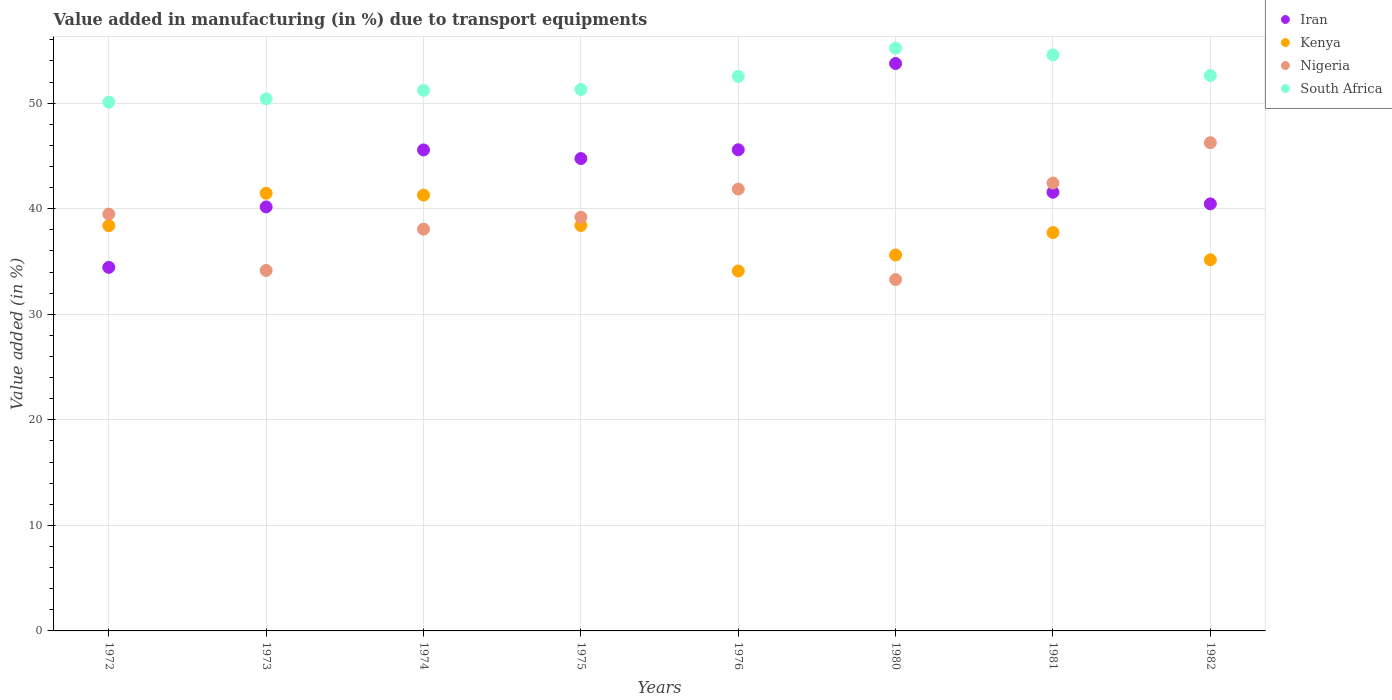How many different coloured dotlines are there?
Give a very brief answer. 4. Is the number of dotlines equal to the number of legend labels?
Your answer should be compact. Yes. What is the percentage of value added in manufacturing due to transport equipments in Nigeria in 1980?
Give a very brief answer. 33.29. Across all years, what is the maximum percentage of value added in manufacturing due to transport equipments in Kenya?
Your answer should be very brief. 41.46. Across all years, what is the minimum percentage of value added in manufacturing due to transport equipments in South Africa?
Make the answer very short. 50.09. In which year was the percentage of value added in manufacturing due to transport equipments in Iran minimum?
Make the answer very short. 1972. What is the total percentage of value added in manufacturing due to transport equipments in Nigeria in the graph?
Keep it short and to the point. 314.71. What is the difference between the percentage of value added in manufacturing due to transport equipments in Kenya in 1973 and that in 1974?
Offer a terse response. 0.17. What is the difference between the percentage of value added in manufacturing due to transport equipments in Kenya in 1973 and the percentage of value added in manufacturing due to transport equipments in South Africa in 1980?
Ensure brevity in your answer.  -13.75. What is the average percentage of value added in manufacturing due to transport equipments in Iran per year?
Keep it short and to the point. 43.28. In the year 1976, what is the difference between the percentage of value added in manufacturing due to transport equipments in Kenya and percentage of value added in manufacturing due to transport equipments in South Africa?
Make the answer very short. -18.43. What is the ratio of the percentage of value added in manufacturing due to transport equipments in Nigeria in 1980 to that in 1981?
Make the answer very short. 0.78. Is the percentage of value added in manufacturing due to transport equipments in Nigeria in 1974 less than that in 1982?
Your response must be concise. Yes. Is the difference between the percentage of value added in manufacturing due to transport equipments in Kenya in 1975 and 1980 greater than the difference between the percentage of value added in manufacturing due to transport equipments in South Africa in 1975 and 1980?
Ensure brevity in your answer.  Yes. What is the difference between the highest and the second highest percentage of value added in manufacturing due to transport equipments in Nigeria?
Offer a very short reply. 3.82. What is the difference between the highest and the lowest percentage of value added in manufacturing due to transport equipments in Nigeria?
Offer a terse response. 12.96. Is the sum of the percentage of value added in manufacturing due to transport equipments in Iran in 1972 and 1981 greater than the maximum percentage of value added in manufacturing due to transport equipments in South Africa across all years?
Ensure brevity in your answer.  Yes. Is it the case that in every year, the sum of the percentage of value added in manufacturing due to transport equipments in Iran and percentage of value added in manufacturing due to transport equipments in South Africa  is greater than the percentage of value added in manufacturing due to transport equipments in Kenya?
Give a very brief answer. Yes. Does the percentage of value added in manufacturing due to transport equipments in Kenya monotonically increase over the years?
Offer a very short reply. No. Is the percentage of value added in manufacturing due to transport equipments in Nigeria strictly less than the percentage of value added in manufacturing due to transport equipments in Kenya over the years?
Keep it short and to the point. No. How many dotlines are there?
Offer a very short reply. 4. How many years are there in the graph?
Your response must be concise. 8. What is the difference between two consecutive major ticks on the Y-axis?
Keep it short and to the point. 10. Are the values on the major ticks of Y-axis written in scientific E-notation?
Your answer should be very brief. No. Does the graph contain any zero values?
Ensure brevity in your answer.  No. How many legend labels are there?
Your answer should be compact. 4. What is the title of the graph?
Keep it short and to the point. Value added in manufacturing (in %) due to transport equipments. Does "Curacao" appear as one of the legend labels in the graph?
Provide a short and direct response. No. What is the label or title of the Y-axis?
Keep it short and to the point. Value added (in %). What is the Value added (in %) of Iran in 1972?
Provide a succinct answer. 34.44. What is the Value added (in %) in Kenya in 1972?
Ensure brevity in your answer.  38.39. What is the Value added (in %) of Nigeria in 1972?
Your response must be concise. 39.49. What is the Value added (in %) in South Africa in 1972?
Give a very brief answer. 50.09. What is the Value added (in %) of Iran in 1973?
Offer a terse response. 40.17. What is the Value added (in %) in Kenya in 1973?
Your response must be concise. 41.46. What is the Value added (in %) in Nigeria in 1973?
Your answer should be compact. 34.15. What is the Value added (in %) of South Africa in 1973?
Your answer should be compact. 50.41. What is the Value added (in %) in Iran in 1974?
Keep it short and to the point. 45.57. What is the Value added (in %) of Kenya in 1974?
Make the answer very short. 41.29. What is the Value added (in %) of Nigeria in 1974?
Keep it short and to the point. 38.06. What is the Value added (in %) of South Africa in 1974?
Give a very brief answer. 51.21. What is the Value added (in %) in Iran in 1975?
Keep it short and to the point. 44.75. What is the Value added (in %) in Kenya in 1975?
Ensure brevity in your answer.  38.41. What is the Value added (in %) in Nigeria in 1975?
Give a very brief answer. 39.19. What is the Value added (in %) in South Africa in 1975?
Ensure brevity in your answer.  51.29. What is the Value added (in %) of Iran in 1976?
Make the answer very short. 45.58. What is the Value added (in %) of Kenya in 1976?
Your answer should be compact. 34.1. What is the Value added (in %) of Nigeria in 1976?
Offer a very short reply. 41.86. What is the Value added (in %) of South Africa in 1976?
Make the answer very short. 52.53. What is the Value added (in %) of Iran in 1980?
Provide a succinct answer. 53.75. What is the Value added (in %) of Kenya in 1980?
Your response must be concise. 35.61. What is the Value added (in %) in Nigeria in 1980?
Provide a short and direct response. 33.29. What is the Value added (in %) in South Africa in 1980?
Your response must be concise. 55.21. What is the Value added (in %) of Iran in 1981?
Keep it short and to the point. 41.56. What is the Value added (in %) in Kenya in 1981?
Offer a terse response. 37.74. What is the Value added (in %) in Nigeria in 1981?
Ensure brevity in your answer.  42.43. What is the Value added (in %) in South Africa in 1981?
Give a very brief answer. 54.56. What is the Value added (in %) in Iran in 1982?
Your answer should be compact. 40.46. What is the Value added (in %) in Kenya in 1982?
Your answer should be compact. 35.16. What is the Value added (in %) of Nigeria in 1982?
Your answer should be compact. 46.25. What is the Value added (in %) in South Africa in 1982?
Provide a short and direct response. 52.62. Across all years, what is the maximum Value added (in %) of Iran?
Ensure brevity in your answer.  53.75. Across all years, what is the maximum Value added (in %) in Kenya?
Your answer should be very brief. 41.46. Across all years, what is the maximum Value added (in %) in Nigeria?
Offer a terse response. 46.25. Across all years, what is the maximum Value added (in %) in South Africa?
Provide a short and direct response. 55.21. Across all years, what is the minimum Value added (in %) in Iran?
Keep it short and to the point. 34.44. Across all years, what is the minimum Value added (in %) in Kenya?
Your answer should be compact. 34.1. Across all years, what is the minimum Value added (in %) in Nigeria?
Offer a very short reply. 33.29. Across all years, what is the minimum Value added (in %) of South Africa?
Make the answer very short. 50.09. What is the total Value added (in %) of Iran in the graph?
Offer a terse response. 346.27. What is the total Value added (in %) of Kenya in the graph?
Ensure brevity in your answer.  302.16. What is the total Value added (in %) of Nigeria in the graph?
Your response must be concise. 314.71. What is the total Value added (in %) in South Africa in the graph?
Ensure brevity in your answer.  417.92. What is the difference between the Value added (in %) of Iran in 1972 and that in 1973?
Your answer should be compact. -5.73. What is the difference between the Value added (in %) in Kenya in 1972 and that in 1973?
Offer a terse response. -3.07. What is the difference between the Value added (in %) in Nigeria in 1972 and that in 1973?
Your answer should be very brief. 5.34. What is the difference between the Value added (in %) in South Africa in 1972 and that in 1973?
Ensure brevity in your answer.  -0.31. What is the difference between the Value added (in %) of Iran in 1972 and that in 1974?
Offer a terse response. -11.13. What is the difference between the Value added (in %) in Kenya in 1972 and that in 1974?
Offer a very short reply. -2.89. What is the difference between the Value added (in %) in Nigeria in 1972 and that in 1974?
Your response must be concise. 1.43. What is the difference between the Value added (in %) of South Africa in 1972 and that in 1974?
Give a very brief answer. -1.11. What is the difference between the Value added (in %) in Iran in 1972 and that in 1975?
Your answer should be very brief. -10.31. What is the difference between the Value added (in %) in Kenya in 1972 and that in 1975?
Keep it short and to the point. -0.02. What is the difference between the Value added (in %) of Nigeria in 1972 and that in 1975?
Offer a very short reply. 0.3. What is the difference between the Value added (in %) of South Africa in 1972 and that in 1975?
Keep it short and to the point. -1.2. What is the difference between the Value added (in %) in Iran in 1972 and that in 1976?
Your answer should be very brief. -11.14. What is the difference between the Value added (in %) in Kenya in 1972 and that in 1976?
Your answer should be compact. 4.29. What is the difference between the Value added (in %) in Nigeria in 1972 and that in 1976?
Provide a succinct answer. -2.37. What is the difference between the Value added (in %) in South Africa in 1972 and that in 1976?
Your answer should be compact. -2.44. What is the difference between the Value added (in %) in Iran in 1972 and that in 1980?
Provide a short and direct response. -19.31. What is the difference between the Value added (in %) of Kenya in 1972 and that in 1980?
Your response must be concise. 2.78. What is the difference between the Value added (in %) of Nigeria in 1972 and that in 1980?
Make the answer very short. 6.2. What is the difference between the Value added (in %) in South Africa in 1972 and that in 1980?
Provide a succinct answer. -5.12. What is the difference between the Value added (in %) of Iran in 1972 and that in 1981?
Offer a very short reply. -7.12. What is the difference between the Value added (in %) in Kenya in 1972 and that in 1981?
Your answer should be compact. 0.65. What is the difference between the Value added (in %) of Nigeria in 1972 and that in 1981?
Your answer should be compact. -2.94. What is the difference between the Value added (in %) in South Africa in 1972 and that in 1981?
Your response must be concise. -4.47. What is the difference between the Value added (in %) of Iran in 1972 and that in 1982?
Keep it short and to the point. -6.02. What is the difference between the Value added (in %) in Kenya in 1972 and that in 1982?
Give a very brief answer. 3.23. What is the difference between the Value added (in %) of Nigeria in 1972 and that in 1982?
Keep it short and to the point. -6.76. What is the difference between the Value added (in %) of South Africa in 1972 and that in 1982?
Your response must be concise. -2.53. What is the difference between the Value added (in %) in Iran in 1973 and that in 1974?
Offer a very short reply. -5.4. What is the difference between the Value added (in %) of Kenya in 1973 and that in 1974?
Offer a very short reply. 0.17. What is the difference between the Value added (in %) in Nigeria in 1973 and that in 1974?
Ensure brevity in your answer.  -3.91. What is the difference between the Value added (in %) of South Africa in 1973 and that in 1974?
Make the answer very short. -0.8. What is the difference between the Value added (in %) of Iran in 1973 and that in 1975?
Provide a short and direct response. -4.58. What is the difference between the Value added (in %) of Kenya in 1973 and that in 1975?
Your answer should be compact. 3.05. What is the difference between the Value added (in %) in Nigeria in 1973 and that in 1975?
Offer a terse response. -5.04. What is the difference between the Value added (in %) in South Africa in 1973 and that in 1975?
Make the answer very short. -0.88. What is the difference between the Value added (in %) in Iran in 1973 and that in 1976?
Offer a very short reply. -5.41. What is the difference between the Value added (in %) in Kenya in 1973 and that in 1976?
Provide a short and direct response. 7.36. What is the difference between the Value added (in %) in Nigeria in 1973 and that in 1976?
Your answer should be compact. -7.71. What is the difference between the Value added (in %) in South Africa in 1973 and that in 1976?
Offer a very short reply. -2.13. What is the difference between the Value added (in %) of Iran in 1973 and that in 1980?
Keep it short and to the point. -13.58. What is the difference between the Value added (in %) of Kenya in 1973 and that in 1980?
Your answer should be very brief. 5.85. What is the difference between the Value added (in %) of Nigeria in 1973 and that in 1980?
Provide a succinct answer. 0.86. What is the difference between the Value added (in %) in South Africa in 1973 and that in 1980?
Make the answer very short. -4.8. What is the difference between the Value added (in %) of Iran in 1973 and that in 1981?
Provide a short and direct response. -1.39. What is the difference between the Value added (in %) of Kenya in 1973 and that in 1981?
Ensure brevity in your answer.  3.72. What is the difference between the Value added (in %) of Nigeria in 1973 and that in 1981?
Offer a very short reply. -8.28. What is the difference between the Value added (in %) of South Africa in 1973 and that in 1981?
Your response must be concise. -4.15. What is the difference between the Value added (in %) of Iran in 1973 and that in 1982?
Your answer should be compact. -0.29. What is the difference between the Value added (in %) in Kenya in 1973 and that in 1982?
Your answer should be very brief. 6.3. What is the difference between the Value added (in %) of Nigeria in 1973 and that in 1982?
Your answer should be very brief. -12.1. What is the difference between the Value added (in %) in South Africa in 1973 and that in 1982?
Offer a very short reply. -2.21. What is the difference between the Value added (in %) of Iran in 1974 and that in 1975?
Offer a very short reply. 0.82. What is the difference between the Value added (in %) of Kenya in 1974 and that in 1975?
Your answer should be very brief. 2.88. What is the difference between the Value added (in %) in Nigeria in 1974 and that in 1975?
Offer a terse response. -1.13. What is the difference between the Value added (in %) in South Africa in 1974 and that in 1975?
Make the answer very short. -0.08. What is the difference between the Value added (in %) of Iran in 1974 and that in 1976?
Give a very brief answer. -0.02. What is the difference between the Value added (in %) of Kenya in 1974 and that in 1976?
Offer a terse response. 7.19. What is the difference between the Value added (in %) in Nigeria in 1974 and that in 1976?
Your answer should be compact. -3.8. What is the difference between the Value added (in %) of South Africa in 1974 and that in 1976?
Give a very brief answer. -1.33. What is the difference between the Value added (in %) of Iran in 1974 and that in 1980?
Give a very brief answer. -8.19. What is the difference between the Value added (in %) of Kenya in 1974 and that in 1980?
Provide a succinct answer. 5.67. What is the difference between the Value added (in %) of Nigeria in 1974 and that in 1980?
Provide a short and direct response. 4.77. What is the difference between the Value added (in %) of South Africa in 1974 and that in 1980?
Ensure brevity in your answer.  -4. What is the difference between the Value added (in %) in Iran in 1974 and that in 1981?
Your answer should be compact. 4. What is the difference between the Value added (in %) in Kenya in 1974 and that in 1981?
Make the answer very short. 3.55. What is the difference between the Value added (in %) in Nigeria in 1974 and that in 1981?
Your answer should be compact. -4.37. What is the difference between the Value added (in %) of South Africa in 1974 and that in 1981?
Offer a very short reply. -3.36. What is the difference between the Value added (in %) of Iran in 1974 and that in 1982?
Keep it short and to the point. 5.11. What is the difference between the Value added (in %) of Kenya in 1974 and that in 1982?
Ensure brevity in your answer.  6.13. What is the difference between the Value added (in %) of Nigeria in 1974 and that in 1982?
Keep it short and to the point. -8.19. What is the difference between the Value added (in %) in South Africa in 1974 and that in 1982?
Your answer should be compact. -1.41. What is the difference between the Value added (in %) of Iran in 1975 and that in 1976?
Keep it short and to the point. -0.83. What is the difference between the Value added (in %) of Kenya in 1975 and that in 1976?
Keep it short and to the point. 4.31. What is the difference between the Value added (in %) in Nigeria in 1975 and that in 1976?
Give a very brief answer. -2.66. What is the difference between the Value added (in %) in South Africa in 1975 and that in 1976?
Your answer should be very brief. -1.24. What is the difference between the Value added (in %) in Iran in 1975 and that in 1980?
Your response must be concise. -9. What is the difference between the Value added (in %) in Kenya in 1975 and that in 1980?
Your response must be concise. 2.8. What is the difference between the Value added (in %) of Nigeria in 1975 and that in 1980?
Make the answer very short. 5.9. What is the difference between the Value added (in %) in South Africa in 1975 and that in 1980?
Your answer should be very brief. -3.92. What is the difference between the Value added (in %) of Iran in 1975 and that in 1981?
Provide a short and direct response. 3.19. What is the difference between the Value added (in %) in Kenya in 1975 and that in 1981?
Give a very brief answer. 0.67. What is the difference between the Value added (in %) in Nigeria in 1975 and that in 1981?
Your response must be concise. -3.24. What is the difference between the Value added (in %) in South Africa in 1975 and that in 1981?
Your answer should be compact. -3.27. What is the difference between the Value added (in %) of Iran in 1975 and that in 1982?
Ensure brevity in your answer.  4.29. What is the difference between the Value added (in %) in Kenya in 1975 and that in 1982?
Keep it short and to the point. 3.25. What is the difference between the Value added (in %) of Nigeria in 1975 and that in 1982?
Your response must be concise. -7.06. What is the difference between the Value added (in %) of South Africa in 1975 and that in 1982?
Your answer should be compact. -1.33. What is the difference between the Value added (in %) in Iran in 1976 and that in 1980?
Your response must be concise. -8.17. What is the difference between the Value added (in %) of Kenya in 1976 and that in 1980?
Your response must be concise. -1.51. What is the difference between the Value added (in %) in Nigeria in 1976 and that in 1980?
Offer a terse response. 8.57. What is the difference between the Value added (in %) of South Africa in 1976 and that in 1980?
Offer a very short reply. -2.68. What is the difference between the Value added (in %) in Iran in 1976 and that in 1981?
Your response must be concise. 4.02. What is the difference between the Value added (in %) of Kenya in 1976 and that in 1981?
Your answer should be compact. -3.64. What is the difference between the Value added (in %) in Nigeria in 1976 and that in 1981?
Provide a short and direct response. -0.57. What is the difference between the Value added (in %) of South Africa in 1976 and that in 1981?
Make the answer very short. -2.03. What is the difference between the Value added (in %) of Iran in 1976 and that in 1982?
Your response must be concise. 5.13. What is the difference between the Value added (in %) of Kenya in 1976 and that in 1982?
Ensure brevity in your answer.  -1.06. What is the difference between the Value added (in %) of Nigeria in 1976 and that in 1982?
Your answer should be compact. -4.4. What is the difference between the Value added (in %) in South Africa in 1976 and that in 1982?
Ensure brevity in your answer.  -0.09. What is the difference between the Value added (in %) of Iran in 1980 and that in 1981?
Offer a very short reply. 12.19. What is the difference between the Value added (in %) in Kenya in 1980 and that in 1981?
Provide a short and direct response. -2.13. What is the difference between the Value added (in %) in Nigeria in 1980 and that in 1981?
Provide a succinct answer. -9.14. What is the difference between the Value added (in %) in South Africa in 1980 and that in 1981?
Your answer should be compact. 0.65. What is the difference between the Value added (in %) of Iran in 1980 and that in 1982?
Ensure brevity in your answer.  13.3. What is the difference between the Value added (in %) of Kenya in 1980 and that in 1982?
Keep it short and to the point. 0.45. What is the difference between the Value added (in %) of Nigeria in 1980 and that in 1982?
Your answer should be very brief. -12.96. What is the difference between the Value added (in %) of South Africa in 1980 and that in 1982?
Give a very brief answer. 2.59. What is the difference between the Value added (in %) of Iran in 1981 and that in 1982?
Your answer should be very brief. 1.1. What is the difference between the Value added (in %) of Kenya in 1981 and that in 1982?
Keep it short and to the point. 2.58. What is the difference between the Value added (in %) in Nigeria in 1981 and that in 1982?
Offer a very short reply. -3.82. What is the difference between the Value added (in %) in South Africa in 1981 and that in 1982?
Give a very brief answer. 1.94. What is the difference between the Value added (in %) in Iran in 1972 and the Value added (in %) in Kenya in 1973?
Ensure brevity in your answer.  -7.02. What is the difference between the Value added (in %) of Iran in 1972 and the Value added (in %) of Nigeria in 1973?
Your answer should be very brief. 0.29. What is the difference between the Value added (in %) of Iran in 1972 and the Value added (in %) of South Africa in 1973?
Provide a short and direct response. -15.97. What is the difference between the Value added (in %) of Kenya in 1972 and the Value added (in %) of Nigeria in 1973?
Make the answer very short. 4.24. What is the difference between the Value added (in %) in Kenya in 1972 and the Value added (in %) in South Africa in 1973?
Your answer should be compact. -12.01. What is the difference between the Value added (in %) of Nigeria in 1972 and the Value added (in %) of South Africa in 1973?
Your answer should be compact. -10.92. What is the difference between the Value added (in %) of Iran in 1972 and the Value added (in %) of Kenya in 1974?
Give a very brief answer. -6.85. What is the difference between the Value added (in %) of Iran in 1972 and the Value added (in %) of Nigeria in 1974?
Your answer should be very brief. -3.62. What is the difference between the Value added (in %) of Iran in 1972 and the Value added (in %) of South Africa in 1974?
Keep it short and to the point. -16.77. What is the difference between the Value added (in %) of Kenya in 1972 and the Value added (in %) of Nigeria in 1974?
Offer a very short reply. 0.33. What is the difference between the Value added (in %) in Kenya in 1972 and the Value added (in %) in South Africa in 1974?
Provide a succinct answer. -12.81. What is the difference between the Value added (in %) in Nigeria in 1972 and the Value added (in %) in South Africa in 1974?
Your answer should be very brief. -11.72. What is the difference between the Value added (in %) in Iran in 1972 and the Value added (in %) in Kenya in 1975?
Keep it short and to the point. -3.97. What is the difference between the Value added (in %) in Iran in 1972 and the Value added (in %) in Nigeria in 1975?
Offer a very short reply. -4.75. What is the difference between the Value added (in %) in Iran in 1972 and the Value added (in %) in South Africa in 1975?
Provide a short and direct response. -16.85. What is the difference between the Value added (in %) in Kenya in 1972 and the Value added (in %) in Nigeria in 1975?
Provide a short and direct response. -0.8. What is the difference between the Value added (in %) in Kenya in 1972 and the Value added (in %) in South Africa in 1975?
Give a very brief answer. -12.9. What is the difference between the Value added (in %) of Nigeria in 1972 and the Value added (in %) of South Africa in 1975?
Offer a very short reply. -11.8. What is the difference between the Value added (in %) in Iran in 1972 and the Value added (in %) in Kenya in 1976?
Your answer should be compact. 0.34. What is the difference between the Value added (in %) of Iran in 1972 and the Value added (in %) of Nigeria in 1976?
Offer a terse response. -7.42. What is the difference between the Value added (in %) in Iran in 1972 and the Value added (in %) in South Africa in 1976?
Keep it short and to the point. -18.09. What is the difference between the Value added (in %) in Kenya in 1972 and the Value added (in %) in Nigeria in 1976?
Keep it short and to the point. -3.46. What is the difference between the Value added (in %) in Kenya in 1972 and the Value added (in %) in South Africa in 1976?
Provide a short and direct response. -14.14. What is the difference between the Value added (in %) in Nigeria in 1972 and the Value added (in %) in South Africa in 1976?
Provide a succinct answer. -13.05. What is the difference between the Value added (in %) in Iran in 1972 and the Value added (in %) in Kenya in 1980?
Ensure brevity in your answer.  -1.17. What is the difference between the Value added (in %) in Iran in 1972 and the Value added (in %) in Nigeria in 1980?
Make the answer very short. 1.15. What is the difference between the Value added (in %) of Iran in 1972 and the Value added (in %) of South Africa in 1980?
Make the answer very short. -20.77. What is the difference between the Value added (in %) of Kenya in 1972 and the Value added (in %) of Nigeria in 1980?
Offer a terse response. 5.1. What is the difference between the Value added (in %) in Kenya in 1972 and the Value added (in %) in South Africa in 1980?
Your response must be concise. -16.82. What is the difference between the Value added (in %) of Nigeria in 1972 and the Value added (in %) of South Africa in 1980?
Offer a very short reply. -15.72. What is the difference between the Value added (in %) in Iran in 1972 and the Value added (in %) in Kenya in 1981?
Provide a succinct answer. -3.3. What is the difference between the Value added (in %) in Iran in 1972 and the Value added (in %) in Nigeria in 1981?
Offer a terse response. -7.99. What is the difference between the Value added (in %) of Iran in 1972 and the Value added (in %) of South Africa in 1981?
Provide a succinct answer. -20.12. What is the difference between the Value added (in %) in Kenya in 1972 and the Value added (in %) in Nigeria in 1981?
Give a very brief answer. -4.04. What is the difference between the Value added (in %) in Kenya in 1972 and the Value added (in %) in South Africa in 1981?
Give a very brief answer. -16.17. What is the difference between the Value added (in %) of Nigeria in 1972 and the Value added (in %) of South Africa in 1981?
Your response must be concise. -15.08. What is the difference between the Value added (in %) in Iran in 1972 and the Value added (in %) in Kenya in 1982?
Your answer should be very brief. -0.72. What is the difference between the Value added (in %) of Iran in 1972 and the Value added (in %) of Nigeria in 1982?
Keep it short and to the point. -11.81. What is the difference between the Value added (in %) in Iran in 1972 and the Value added (in %) in South Africa in 1982?
Your answer should be compact. -18.18. What is the difference between the Value added (in %) in Kenya in 1972 and the Value added (in %) in Nigeria in 1982?
Offer a very short reply. -7.86. What is the difference between the Value added (in %) of Kenya in 1972 and the Value added (in %) of South Africa in 1982?
Your answer should be compact. -14.23. What is the difference between the Value added (in %) of Nigeria in 1972 and the Value added (in %) of South Africa in 1982?
Your answer should be very brief. -13.13. What is the difference between the Value added (in %) of Iran in 1973 and the Value added (in %) of Kenya in 1974?
Offer a terse response. -1.12. What is the difference between the Value added (in %) in Iran in 1973 and the Value added (in %) in Nigeria in 1974?
Offer a terse response. 2.11. What is the difference between the Value added (in %) of Iran in 1973 and the Value added (in %) of South Africa in 1974?
Give a very brief answer. -11.04. What is the difference between the Value added (in %) in Kenya in 1973 and the Value added (in %) in Nigeria in 1974?
Ensure brevity in your answer.  3.4. What is the difference between the Value added (in %) of Kenya in 1973 and the Value added (in %) of South Africa in 1974?
Give a very brief answer. -9.75. What is the difference between the Value added (in %) of Nigeria in 1973 and the Value added (in %) of South Africa in 1974?
Your answer should be very brief. -17.06. What is the difference between the Value added (in %) in Iran in 1973 and the Value added (in %) in Kenya in 1975?
Give a very brief answer. 1.76. What is the difference between the Value added (in %) in Iran in 1973 and the Value added (in %) in Nigeria in 1975?
Offer a terse response. 0.98. What is the difference between the Value added (in %) of Iran in 1973 and the Value added (in %) of South Africa in 1975?
Your answer should be compact. -11.12. What is the difference between the Value added (in %) in Kenya in 1973 and the Value added (in %) in Nigeria in 1975?
Make the answer very short. 2.27. What is the difference between the Value added (in %) in Kenya in 1973 and the Value added (in %) in South Africa in 1975?
Provide a short and direct response. -9.83. What is the difference between the Value added (in %) of Nigeria in 1973 and the Value added (in %) of South Africa in 1975?
Give a very brief answer. -17.14. What is the difference between the Value added (in %) in Iran in 1973 and the Value added (in %) in Kenya in 1976?
Offer a terse response. 6.07. What is the difference between the Value added (in %) of Iran in 1973 and the Value added (in %) of Nigeria in 1976?
Offer a terse response. -1.69. What is the difference between the Value added (in %) of Iran in 1973 and the Value added (in %) of South Africa in 1976?
Keep it short and to the point. -12.37. What is the difference between the Value added (in %) in Kenya in 1973 and the Value added (in %) in Nigeria in 1976?
Your answer should be very brief. -0.4. What is the difference between the Value added (in %) of Kenya in 1973 and the Value added (in %) of South Africa in 1976?
Ensure brevity in your answer.  -11.07. What is the difference between the Value added (in %) in Nigeria in 1973 and the Value added (in %) in South Africa in 1976?
Provide a succinct answer. -18.38. What is the difference between the Value added (in %) of Iran in 1973 and the Value added (in %) of Kenya in 1980?
Offer a terse response. 4.56. What is the difference between the Value added (in %) in Iran in 1973 and the Value added (in %) in Nigeria in 1980?
Offer a very short reply. 6.88. What is the difference between the Value added (in %) of Iran in 1973 and the Value added (in %) of South Africa in 1980?
Keep it short and to the point. -15.04. What is the difference between the Value added (in %) in Kenya in 1973 and the Value added (in %) in Nigeria in 1980?
Make the answer very short. 8.17. What is the difference between the Value added (in %) of Kenya in 1973 and the Value added (in %) of South Africa in 1980?
Provide a succinct answer. -13.75. What is the difference between the Value added (in %) in Nigeria in 1973 and the Value added (in %) in South Africa in 1980?
Provide a short and direct response. -21.06. What is the difference between the Value added (in %) of Iran in 1973 and the Value added (in %) of Kenya in 1981?
Your answer should be compact. 2.43. What is the difference between the Value added (in %) in Iran in 1973 and the Value added (in %) in Nigeria in 1981?
Your response must be concise. -2.26. What is the difference between the Value added (in %) of Iran in 1973 and the Value added (in %) of South Africa in 1981?
Offer a terse response. -14.39. What is the difference between the Value added (in %) in Kenya in 1973 and the Value added (in %) in Nigeria in 1981?
Make the answer very short. -0.97. What is the difference between the Value added (in %) in Kenya in 1973 and the Value added (in %) in South Africa in 1981?
Your answer should be compact. -13.1. What is the difference between the Value added (in %) in Nigeria in 1973 and the Value added (in %) in South Africa in 1981?
Make the answer very short. -20.41. What is the difference between the Value added (in %) of Iran in 1973 and the Value added (in %) of Kenya in 1982?
Ensure brevity in your answer.  5.01. What is the difference between the Value added (in %) in Iran in 1973 and the Value added (in %) in Nigeria in 1982?
Your answer should be compact. -6.08. What is the difference between the Value added (in %) in Iran in 1973 and the Value added (in %) in South Africa in 1982?
Give a very brief answer. -12.45. What is the difference between the Value added (in %) in Kenya in 1973 and the Value added (in %) in Nigeria in 1982?
Ensure brevity in your answer.  -4.79. What is the difference between the Value added (in %) in Kenya in 1973 and the Value added (in %) in South Africa in 1982?
Provide a short and direct response. -11.16. What is the difference between the Value added (in %) of Nigeria in 1973 and the Value added (in %) of South Africa in 1982?
Offer a very short reply. -18.47. What is the difference between the Value added (in %) of Iran in 1974 and the Value added (in %) of Kenya in 1975?
Your response must be concise. 7.16. What is the difference between the Value added (in %) of Iran in 1974 and the Value added (in %) of Nigeria in 1975?
Provide a short and direct response. 6.37. What is the difference between the Value added (in %) of Iran in 1974 and the Value added (in %) of South Africa in 1975?
Provide a short and direct response. -5.72. What is the difference between the Value added (in %) of Kenya in 1974 and the Value added (in %) of Nigeria in 1975?
Give a very brief answer. 2.09. What is the difference between the Value added (in %) of Kenya in 1974 and the Value added (in %) of South Africa in 1975?
Offer a terse response. -10.01. What is the difference between the Value added (in %) of Nigeria in 1974 and the Value added (in %) of South Africa in 1975?
Give a very brief answer. -13.23. What is the difference between the Value added (in %) in Iran in 1974 and the Value added (in %) in Kenya in 1976?
Give a very brief answer. 11.47. What is the difference between the Value added (in %) of Iran in 1974 and the Value added (in %) of Nigeria in 1976?
Provide a succinct answer. 3.71. What is the difference between the Value added (in %) of Iran in 1974 and the Value added (in %) of South Africa in 1976?
Provide a short and direct response. -6.97. What is the difference between the Value added (in %) of Kenya in 1974 and the Value added (in %) of Nigeria in 1976?
Your response must be concise. -0.57. What is the difference between the Value added (in %) in Kenya in 1974 and the Value added (in %) in South Africa in 1976?
Offer a very short reply. -11.25. What is the difference between the Value added (in %) of Nigeria in 1974 and the Value added (in %) of South Africa in 1976?
Provide a succinct answer. -14.47. What is the difference between the Value added (in %) of Iran in 1974 and the Value added (in %) of Kenya in 1980?
Offer a terse response. 9.95. What is the difference between the Value added (in %) of Iran in 1974 and the Value added (in %) of Nigeria in 1980?
Offer a very short reply. 12.28. What is the difference between the Value added (in %) of Iran in 1974 and the Value added (in %) of South Africa in 1980?
Keep it short and to the point. -9.64. What is the difference between the Value added (in %) in Kenya in 1974 and the Value added (in %) in Nigeria in 1980?
Provide a short and direct response. 8. What is the difference between the Value added (in %) in Kenya in 1974 and the Value added (in %) in South Africa in 1980?
Provide a succinct answer. -13.92. What is the difference between the Value added (in %) in Nigeria in 1974 and the Value added (in %) in South Africa in 1980?
Your answer should be very brief. -17.15. What is the difference between the Value added (in %) of Iran in 1974 and the Value added (in %) of Kenya in 1981?
Offer a very short reply. 7.83. What is the difference between the Value added (in %) of Iran in 1974 and the Value added (in %) of Nigeria in 1981?
Offer a very short reply. 3.14. What is the difference between the Value added (in %) of Iran in 1974 and the Value added (in %) of South Africa in 1981?
Provide a short and direct response. -9. What is the difference between the Value added (in %) in Kenya in 1974 and the Value added (in %) in Nigeria in 1981?
Keep it short and to the point. -1.14. What is the difference between the Value added (in %) in Kenya in 1974 and the Value added (in %) in South Africa in 1981?
Offer a terse response. -13.28. What is the difference between the Value added (in %) of Nigeria in 1974 and the Value added (in %) of South Africa in 1981?
Give a very brief answer. -16.5. What is the difference between the Value added (in %) in Iran in 1974 and the Value added (in %) in Kenya in 1982?
Your answer should be very brief. 10.41. What is the difference between the Value added (in %) of Iran in 1974 and the Value added (in %) of Nigeria in 1982?
Give a very brief answer. -0.69. What is the difference between the Value added (in %) in Iran in 1974 and the Value added (in %) in South Africa in 1982?
Your answer should be compact. -7.05. What is the difference between the Value added (in %) of Kenya in 1974 and the Value added (in %) of Nigeria in 1982?
Offer a very short reply. -4.97. What is the difference between the Value added (in %) of Kenya in 1974 and the Value added (in %) of South Africa in 1982?
Ensure brevity in your answer.  -11.33. What is the difference between the Value added (in %) of Nigeria in 1974 and the Value added (in %) of South Africa in 1982?
Keep it short and to the point. -14.56. What is the difference between the Value added (in %) in Iran in 1975 and the Value added (in %) in Kenya in 1976?
Keep it short and to the point. 10.65. What is the difference between the Value added (in %) in Iran in 1975 and the Value added (in %) in Nigeria in 1976?
Ensure brevity in your answer.  2.89. What is the difference between the Value added (in %) in Iran in 1975 and the Value added (in %) in South Africa in 1976?
Give a very brief answer. -7.78. What is the difference between the Value added (in %) in Kenya in 1975 and the Value added (in %) in Nigeria in 1976?
Provide a short and direct response. -3.45. What is the difference between the Value added (in %) in Kenya in 1975 and the Value added (in %) in South Africa in 1976?
Give a very brief answer. -14.12. What is the difference between the Value added (in %) in Nigeria in 1975 and the Value added (in %) in South Africa in 1976?
Provide a short and direct response. -13.34. What is the difference between the Value added (in %) of Iran in 1975 and the Value added (in %) of Kenya in 1980?
Give a very brief answer. 9.14. What is the difference between the Value added (in %) in Iran in 1975 and the Value added (in %) in Nigeria in 1980?
Your answer should be compact. 11.46. What is the difference between the Value added (in %) in Iran in 1975 and the Value added (in %) in South Africa in 1980?
Make the answer very short. -10.46. What is the difference between the Value added (in %) of Kenya in 1975 and the Value added (in %) of Nigeria in 1980?
Provide a succinct answer. 5.12. What is the difference between the Value added (in %) of Kenya in 1975 and the Value added (in %) of South Africa in 1980?
Provide a short and direct response. -16.8. What is the difference between the Value added (in %) in Nigeria in 1975 and the Value added (in %) in South Africa in 1980?
Make the answer very short. -16.02. What is the difference between the Value added (in %) in Iran in 1975 and the Value added (in %) in Kenya in 1981?
Ensure brevity in your answer.  7.01. What is the difference between the Value added (in %) of Iran in 1975 and the Value added (in %) of Nigeria in 1981?
Your response must be concise. 2.32. What is the difference between the Value added (in %) of Iran in 1975 and the Value added (in %) of South Africa in 1981?
Your answer should be compact. -9.81. What is the difference between the Value added (in %) in Kenya in 1975 and the Value added (in %) in Nigeria in 1981?
Offer a terse response. -4.02. What is the difference between the Value added (in %) of Kenya in 1975 and the Value added (in %) of South Africa in 1981?
Ensure brevity in your answer.  -16.15. What is the difference between the Value added (in %) of Nigeria in 1975 and the Value added (in %) of South Africa in 1981?
Provide a short and direct response. -15.37. What is the difference between the Value added (in %) in Iran in 1975 and the Value added (in %) in Kenya in 1982?
Make the answer very short. 9.59. What is the difference between the Value added (in %) of Iran in 1975 and the Value added (in %) of Nigeria in 1982?
Make the answer very short. -1.5. What is the difference between the Value added (in %) of Iran in 1975 and the Value added (in %) of South Africa in 1982?
Give a very brief answer. -7.87. What is the difference between the Value added (in %) of Kenya in 1975 and the Value added (in %) of Nigeria in 1982?
Provide a short and direct response. -7.84. What is the difference between the Value added (in %) of Kenya in 1975 and the Value added (in %) of South Africa in 1982?
Offer a very short reply. -14.21. What is the difference between the Value added (in %) of Nigeria in 1975 and the Value added (in %) of South Africa in 1982?
Make the answer very short. -13.43. What is the difference between the Value added (in %) in Iran in 1976 and the Value added (in %) in Kenya in 1980?
Your answer should be compact. 9.97. What is the difference between the Value added (in %) in Iran in 1976 and the Value added (in %) in Nigeria in 1980?
Make the answer very short. 12.29. What is the difference between the Value added (in %) of Iran in 1976 and the Value added (in %) of South Africa in 1980?
Your answer should be compact. -9.63. What is the difference between the Value added (in %) in Kenya in 1976 and the Value added (in %) in Nigeria in 1980?
Offer a terse response. 0.81. What is the difference between the Value added (in %) of Kenya in 1976 and the Value added (in %) of South Africa in 1980?
Make the answer very short. -21.11. What is the difference between the Value added (in %) of Nigeria in 1976 and the Value added (in %) of South Africa in 1980?
Give a very brief answer. -13.35. What is the difference between the Value added (in %) of Iran in 1976 and the Value added (in %) of Kenya in 1981?
Give a very brief answer. 7.84. What is the difference between the Value added (in %) in Iran in 1976 and the Value added (in %) in Nigeria in 1981?
Your response must be concise. 3.15. What is the difference between the Value added (in %) in Iran in 1976 and the Value added (in %) in South Africa in 1981?
Your response must be concise. -8.98. What is the difference between the Value added (in %) of Kenya in 1976 and the Value added (in %) of Nigeria in 1981?
Your answer should be compact. -8.33. What is the difference between the Value added (in %) in Kenya in 1976 and the Value added (in %) in South Africa in 1981?
Your response must be concise. -20.46. What is the difference between the Value added (in %) of Nigeria in 1976 and the Value added (in %) of South Africa in 1981?
Your answer should be very brief. -12.71. What is the difference between the Value added (in %) of Iran in 1976 and the Value added (in %) of Kenya in 1982?
Provide a short and direct response. 10.42. What is the difference between the Value added (in %) of Iran in 1976 and the Value added (in %) of Nigeria in 1982?
Your response must be concise. -0.67. What is the difference between the Value added (in %) in Iran in 1976 and the Value added (in %) in South Africa in 1982?
Offer a terse response. -7.04. What is the difference between the Value added (in %) of Kenya in 1976 and the Value added (in %) of Nigeria in 1982?
Your answer should be very brief. -12.15. What is the difference between the Value added (in %) of Kenya in 1976 and the Value added (in %) of South Africa in 1982?
Your answer should be compact. -18.52. What is the difference between the Value added (in %) of Nigeria in 1976 and the Value added (in %) of South Africa in 1982?
Provide a short and direct response. -10.76. What is the difference between the Value added (in %) in Iran in 1980 and the Value added (in %) in Kenya in 1981?
Keep it short and to the point. 16.01. What is the difference between the Value added (in %) in Iran in 1980 and the Value added (in %) in Nigeria in 1981?
Offer a terse response. 11.32. What is the difference between the Value added (in %) in Iran in 1980 and the Value added (in %) in South Africa in 1981?
Offer a terse response. -0.81. What is the difference between the Value added (in %) in Kenya in 1980 and the Value added (in %) in Nigeria in 1981?
Provide a short and direct response. -6.82. What is the difference between the Value added (in %) in Kenya in 1980 and the Value added (in %) in South Africa in 1981?
Make the answer very short. -18.95. What is the difference between the Value added (in %) in Nigeria in 1980 and the Value added (in %) in South Africa in 1981?
Keep it short and to the point. -21.27. What is the difference between the Value added (in %) in Iran in 1980 and the Value added (in %) in Kenya in 1982?
Your answer should be compact. 18.59. What is the difference between the Value added (in %) of Iran in 1980 and the Value added (in %) of Nigeria in 1982?
Offer a terse response. 7.5. What is the difference between the Value added (in %) in Iran in 1980 and the Value added (in %) in South Africa in 1982?
Give a very brief answer. 1.13. What is the difference between the Value added (in %) in Kenya in 1980 and the Value added (in %) in Nigeria in 1982?
Provide a short and direct response. -10.64. What is the difference between the Value added (in %) of Kenya in 1980 and the Value added (in %) of South Africa in 1982?
Keep it short and to the point. -17.01. What is the difference between the Value added (in %) of Nigeria in 1980 and the Value added (in %) of South Africa in 1982?
Your response must be concise. -19.33. What is the difference between the Value added (in %) in Iran in 1981 and the Value added (in %) in Kenya in 1982?
Ensure brevity in your answer.  6.4. What is the difference between the Value added (in %) in Iran in 1981 and the Value added (in %) in Nigeria in 1982?
Your answer should be compact. -4.69. What is the difference between the Value added (in %) in Iran in 1981 and the Value added (in %) in South Africa in 1982?
Offer a terse response. -11.06. What is the difference between the Value added (in %) of Kenya in 1981 and the Value added (in %) of Nigeria in 1982?
Provide a short and direct response. -8.51. What is the difference between the Value added (in %) of Kenya in 1981 and the Value added (in %) of South Africa in 1982?
Keep it short and to the point. -14.88. What is the difference between the Value added (in %) in Nigeria in 1981 and the Value added (in %) in South Africa in 1982?
Your answer should be compact. -10.19. What is the average Value added (in %) in Iran per year?
Your answer should be very brief. 43.28. What is the average Value added (in %) in Kenya per year?
Provide a short and direct response. 37.77. What is the average Value added (in %) in Nigeria per year?
Provide a succinct answer. 39.34. What is the average Value added (in %) in South Africa per year?
Give a very brief answer. 52.24. In the year 1972, what is the difference between the Value added (in %) of Iran and Value added (in %) of Kenya?
Make the answer very short. -3.95. In the year 1972, what is the difference between the Value added (in %) of Iran and Value added (in %) of Nigeria?
Make the answer very short. -5.05. In the year 1972, what is the difference between the Value added (in %) in Iran and Value added (in %) in South Africa?
Offer a very short reply. -15.65. In the year 1972, what is the difference between the Value added (in %) in Kenya and Value added (in %) in Nigeria?
Ensure brevity in your answer.  -1.09. In the year 1972, what is the difference between the Value added (in %) of Kenya and Value added (in %) of South Africa?
Offer a very short reply. -11.7. In the year 1972, what is the difference between the Value added (in %) of Nigeria and Value added (in %) of South Africa?
Give a very brief answer. -10.61. In the year 1973, what is the difference between the Value added (in %) in Iran and Value added (in %) in Kenya?
Give a very brief answer. -1.29. In the year 1973, what is the difference between the Value added (in %) of Iran and Value added (in %) of Nigeria?
Provide a short and direct response. 6.02. In the year 1973, what is the difference between the Value added (in %) in Iran and Value added (in %) in South Africa?
Offer a terse response. -10.24. In the year 1973, what is the difference between the Value added (in %) in Kenya and Value added (in %) in Nigeria?
Offer a very short reply. 7.31. In the year 1973, what is the difference between the Value added (in %) in Kenya and Value added (in %) in South Africa?
Provide a succinct answer. -8.95. In the year 1973, what is the difference between the Value added (in %) in Nigeria and Value added (in %) in South Africa?
Provide a succinct answer. -16.26. In the year 1974, what is the difference between the Value added (in %) of Iran and Value added (in %) of Kenya?
Provide a succinct answer. 4.28. In the year 1974, what is the difference between the Value added (in %) of Iran and Value added (in %) of Nigeria?
Provide a succinct answer. 7.5. In the year 1974, what is the difference between the Value added (in %) of Iran and Value added (in %) of South Africa?
Offer a terse response. -5.64. In the year 1974, what is the difference between the Value added (in %) in Kenya and Value added (in %) in Nigeria?
Keep it short and to the point. 3.22. In the year 1974, what is the difference between the Value added (in %) of Kenya and Value added (in %) of South Africa?
Your response must be concise. -9.92. In the year 1974, what is the difference between the Value added (in %) of Nigeria and Value added (in %) of South Africa?
Your response must be concise. -13.15. In the year 1975, what is the difference between the Value added (in %) in Iran and Value added (in %) in Kenya?
Offer a terse response. 6.34. In the year 1975, what is the difference between the Value added (in %) of Iran and Value added (in %) of Nigeria?
Your answer should be very brief. 5.56. In the year 1975, what is the difference between the Value added (in %) in Iran and Value added (in %) in South Africa?
Make the answer very short. -6.54. In the year 1975, what is the difference between the Value added (in %) of Kenya and Value added (in %) of Nigeria?
Make the answer very short. -0.78. In the year 1975, what is the difference between the Value added (in %) in Kenya and Value added (in %) in South Africa?
Offer a terse response. -12.88. In the year 1975, what is the difference between the Value added (in %) in Nigeria and Value added (in %) in South Africa?
Give a very brief answer. -12.1. In the year 1976, what is the difference between the Value added (in %) in Iran and Value added (in %) in Kenya?
Provide a succinct answer. 11.48. In the year 1976, what is the difference between the Value added (in %) of Iran and Value added (in %) of Nigeria?
Your answer should be very brief. 3.73. In the year 1976, what is the difference between the Value added (in %) in Iran and Value added (in %) in South Africa?
Give a very brief answer. -6.95. In the year 1976, what is the difference between the Value added (in %) of Kenya and Value added (in %) of Nigeria?
Keep it short and to the point. -7.76. In the year 1976, what is the difference between the Value added (in %) in Kenya and Value added (in %) in South Africa?
Make the answer very short. -18.43. In the year 1976, what is the difference between the Value added (in %) in Nigeria and Value added (in %) in South Africa?
Ensure brevity in your answer.  -10.68. In the year 1980, what is the difference between the Value added (in %) of Iran and Value added (in %) of Kenya?
Offer a very short reply. 18.14. In the year 1980, what is the difference between the Value added (in %) in Iran and Value added (in %) in Nigeria?
Keep it short and to the point. 20.46. In the year 1980, what is the difference between the Value added (in %) of Iran and Value added (in %) of South Africa?
Make the answer very short. -1.46. In the year 1980, what is the difference between the Value added (in %) in Kenya and Value added (in %) in Nigeria?
Make the answer very short. 2.32. In the year 1980, what is the difference between the Value added (in %) in Kenya and Value added (in %) in South Africa?
Offer a very short reply. -19.6. In the year 1980, what is the difference between the Value added (in %) in Nigeria and Value added (in %) in South Africa?
Make the answer very short. -21.92. In the year 1981, what is the difference between the Value added (in %) in Iran and Value added (in %) in Kenya?
Keep it short and to the point. 3.82. In the year 1981, what is the difference between the Value added (in %) of Iran and Value added (in %) of Nigeria?
Keep it short and to the point. -0.87. In the year 1981, what is the difference between the Value added (in %) of Iran and Value added (in %) of South Africa?
Provide a short and direct response. -13. In the year 1981, what is the difference between the Value added (in %) in Kenya and Value added (in %) in Nigeria?
Make the answer very short. -4.69. In the year 1981, what is the difference between the Value added (in %) in Kenya and Value added (in %) in South Africa?
Provide a succinct answer. -16.82. In the year 1981, what is the difference between the Value added (in %) in Nigeria and Value added (in %) in South Africa?
Your answer should be compact. -12.13. In the year 1982, what is the difference between the Value added (in %) of Iran and Value added (in %) of Kenya?
Make the answer very short. 5.3. In the year 1982, what is the difference between the Value added (in %) of Iran and Value added (in %) of Nigeria?
Your answer should be compact. -5.8. In the year 1982, what is the difference between the Value added (in %) of Iran and Value added (in %) of South Africa?
Provide a succinct answer. -12.16. In the year 1982, what is the difference between the Value added (in %) in Kenya and Value added (in %) in Nigeria?
Your answer should be very brief. -11.09. In the year 1982, what is the difference between the Value added (in %) in Kenya and Value added (in %) in South Africa?
Ensure brevity in your answer.  -17.46. In the year 1982, what is the difference between the Value added (in %) of Nigeria and Value added (in %) of South Africa?
Offer a terse response. -6.37. What is the ratio of the Value added (in %) in Iran in 1972 to that in 1973?
Offer a terse response. 0.86. What is the ratio of the Value added (in %) of Kenya in 1972 to that in 1973?
Provide a succinct answer. 0.93. What is the ratio of the Value added (in %) of Nigeria in 1972 to that in 1973?
Your answer should be very brief. 1.16. What is the ratio of the Value added (in %) of Iran in 1972 to that in 1974?
Provide a succinct answer. 0.76. What is the ratio of the Value added (in %) in Kenya in 1972 to that in 1974?
Make the answer very short. 0.93. What is the ratio of the Value added (in %) in Nigeria in 1972 to that in 1974?
Your answer should be compact. 1.04. What is the ratio of the Value added (in %) in South Africa in 1972 to that in 1974?
Offer a very short reply. 0.98. What is the ratio of the Value added (in %) of Iran in 1972 to that in 1975?
Offer a very short reply. 0.77. What is the ratio of the Value added (in %) in Nigeria in 1972 to that in 1975?
Offer a terse response. 1.01. What is the ratio of the Value added (in %) in South Africa in 1972 to that in 1975?
Ensure brevity in your answer.  0.98. What is the ratio of the Value added (in %) in Iran in 1972 to that in 1976?
Your response must be concise. 0.76. What is the ratio of the Value added (in %) of Kenya in 1972 to that in 1976?
Offer a terse response. 1.13. What is the ratio of the Value added (in %) of Nigeria in 1972 to that in 1976?
Provide a short and direct response. 0.94. What is the ratio of the Value added (in %) of South Africa in 1972 to that in 1976?
Your answer should be compact. 0.95. What is the ratio of the Value added (in %) of Iran in 1972 to that in 1980?
Ensure brevity in your answer.  0.64. What is the ratio of the Value added (in %) of Kenya in 1972 to that in 1980?
Give a very brief answer. 1.08. What is the ratio of the Value added (in %) in Nigeria in 1972 to that in 1980?
Provide a succinct answer. 1.19. What is the ratio of the Value added (in %) of South Africa in 1972 to that in 1980?
Your answer should be compact. 0.91. What is the ratio of the Value added (in %) in Iran in 1972 to that in 1981?
Make the answer very short. 0.83. What is the ratio of the Value added (in %) of Kenya in 1972 to that in 1981?
Ensure brevity in your answer.  1.02. What is the ratio of the Value added (in %) in Nigeria in 1972 to that in 1981?
Your answer should be very brief. 0.93. What is the ratio of the Value added (in %) of South Africa in 1972 to that in 1981?
Provide a succinct answer. 0.92. What is the ratio of the Value added (in %) in Iran in 1972 to that in 1982?
Give a very brief answer. 0.85. What is the ratio of the Value added (in %) of Kenya in 1972 to that in 1982?
Offer a very short reply. 1.09. What is the ratio of the Value added (in %) in Nigeria in 1972 to that in 1982?
Make the answer very short. 0.85. What is the ratio of the Value added (in %) of South Africa in 1972 to that in 1982?
Provide a succinct answer. 0.95. What is the ratio of the Value added (in %) in Iran in 1973 to that in 1974?
Offer a terse response. 0.88. What is the ratio of the Value added (in %) of Nigeria in 1973 to that in 1974?
Your response must be concise. 0.9. What is the ratio of the Value added (in %) of South Africa in 1973 to that in 1974?
Your response must be concise. 0.98. What is the ratio of the Value added (in %) of Iran in 1973 to that in 1975?
Ensure brevity in your answer.  0.9. What is the ratio of the Value added (in %) of Kenya in 1973 to that in 1975?
Ensure brevity in your answer.  1.08. What is the ratio of the Value added (in %) in Nigeria in 1973 to that in 1975?
Your answer should be very brief. 0.87. What is the ratio of the Value added (in %) in South Africa in 1973 to that in 1975?
Your response must be concise. 0.98. What is the ratio of the Value added (in %) in Iran in 1973 to that in 1976?
Make the answer very short. 0.88. What is the ratio of the Value added (in %) of Kenya in 1973 to that in 1976?
Your response must be concise. 1.22. What is the ratio of the Value added (in %) of Nigeria in 1973 to that in 1976?
Your answer should be very brief. 0.82. What is the ratio of the Value added (in %) in South Africa in 1973 to that in 1976?
Give a very brief answer. 0.96. What is the ratio of the Value added (in %) of Iran in 1973 to that in 1980?
Ensure brevity in your answer.  0.75. What is the ratio of the Value added (in %) in Kenya in 1973 to that in 1980?
Offer a terse response. 1.16. What is the ratio of the Value added (in %) in Nigeria in 1973 to that in 1980?
Your response must be concise. 1.03. What is the ratio of the Value added (in %) in Iran in 1973 to that in 1981?
Provide a short and direct response. 0.97. What is the ratio of the Value added (in %) in Kenya in 1973 to that in 1981?
Your response must be concise. 1.1. What is the ratio of the Value added (in %) in Nigeria in 1973 to that in 1981?
Ensure brevity in your answer.  0.8. What is the ratio of the Value added (in %) of South Africa in 1973 to that in 1981?
Ensure brevity in your answer.  0.92. What is the ratio of the Value added (in %) in Kenya in 1973 to that in 1982?
Ensure brevity in your answer.  1.18. What is the ratio of the Value added (in %) of Nigeria in 1973 to that in 1982?
Your response must be concise. 0.74. What is the ratio of the Value added (in %) in South Africa in 1973 to that in 1982?
Offer a very short reply. 0.96. What is the ratio of the Value added (in %) of Iran in 1974 to that in 1975?
Your answer should be very brief. 1.02. What is the ratio of the Value added (in %) of Kenya in 1974 to that in 1975?
Give a very brief answer. 1.07. What is the ratio of the Value added (in %) of Nigeria in 1974 to that in 1975?
Your answer should be very brief. 0.97. What is the ratio of the Value added (in %) in Kenya in 1974 to that in 1976?
Give a very brief answer. 1.21. What is the ratio of the Value added (in %) in Nigeria in 1974 to that in 1976?
Provide a short and direct response. 0.91. What is the ratio of the Value added (in %) in South Africa in 1974 to that in 1976?
Provide a succinct answer. 0.97. What is the ratio of the Value added (in %) in Iran in 1974 to that in 1980?
Ensure brevity in your answer.  0.85. What is the ratio of the Value added (in %) of Kenya in 1974 to that in 1980?
Keep it short and to the point. 1.16. What is the ratio of the Value added (in %) of Nigeria in 1974 to that in 1980?
Give a very brief answer. 1.14. What is the ratio of the Value added (in %) in South Africa in 1974 to that in 1980?
Your response must be concise. 0.93. What is the ratio of the Value added (in %) of Iran in 1974 to that in 1981?
Make the answer very short. 1.1. What is the ratio of the Value added (in %) in Kenya in 1974 to that in 1981?
Keep it short and to the point. 1.09. What is the ratio of the Value added (in %) in Nigeria in 1974 to that in 1981?
Your response must be concise. 0.9. What is the ratio of the Value added (in %) of South Africa in 1974 to that in 1981?
Your response must be concise. 0.94. What is the ratio of the Value added (in %) in Iran in 1974 to that in 1982?
Keep it short and to the point. 1.13. What is the ratio of the Value added (in %) of Kenya in 1974 to that in 1982?
Your response must be concise. 1.17. What is the ratio of the Value added (in %) of Nigeria in 1974 to that in 1982?
Ensure brevity in your answer.  0.82. What is the ratio of the Value added (in %) of South Africa in 1974 to that in 1982?
Provide a succinct answer. 0.97. What is the ratio of the Value added (in %) in Iran in 1975 to that in 1976?
Keep it short and to the point. 0.98. What is the ratio of the Value added (in %) in Kenya in 1975 to that in 1976?
Keep it short and to the point. 1.13. What is the ratio of the Value added (in %) of Nigeria in 1975 to that in 1976?
Your answer should be compact. 0.94. What is the ratio of the Value added (in %) in South Africa in 1975 to that in 1976?
Provide a short and direct response. 0.98. What is the ratio of the Value added (in %) of Iran in 1975 to that in 1980?
Your answer should be compact. 0.83. What is the ratio of the Value added (in %) of Kenya in 1975 to that in 1980?
Offer a very short reply. 1.08. What is the ratio of the Value added (in %) in Nigeria in 1975 to that in 1980?
Give a very brief answer. 1.18. What is the ratio of the Value added (in %) in South Africa in 1975 to that in 1980?
Provide a short and direct response. 0.93. What is the ratio of the Value added (in %) of Iran in 1975 to that in 1981?
Provide a short and direct response. 1.08. What is the ratio of the Value added (in %) of Kenya in 1975 to that in 1981?
Offer a terse response. 1.02. What is the ratio of the Value added (in %) of Nigeria in 1975 to that in 1981?
Provide a short and direct response. 0.92. What is the ratio of the Value added (in %) in South Africa in 1975 to that in 1981?
Provide a short and direct response. 0.94. What is the ratio of the Value added (in %) in Iran in 1975 to that in 1982?
Your response must be concise. 1.11. What is the ratio of the Value added (in %) of Kenya in 1975 to that in 1982?
Offer a very short reply. 1.09. What is the ratio of the Value added (in %) in Nigeria in 1975 to that in 1982?
Your answer should be very brief. 0.85. What is the ratio of the Value added (in %) of South Africa in 1975 to that in 1982?
Keep it short and to the point. 0.97. What is the ratio of the Value added (in %) of Iran in 1976 to that in 1980?
Your response must be concise. 0.85. What is the ratio of the Value added (in %) in Kenya in 1976 to that in 1980?
Provide a succinct answer. 0.96. What is the ratio of the Value added (in %) in Nigeria in 1976 to that in 1980?
Give a very brief answer. 1.26. What is the ratio of the Value added (in %) of South Africa in 1976 to that in 1980?
Provide a short and direct response. 0.95. What is the ratio of the Value added (in %) in Iran in 1976 to that in 1981?
Offer a very short reply. 1.1. What is the ratio of the Value added (in %) of Kenya in 1976 to that in 1981?
Offer a very short reply. 0.9. What is the ratio of the Value added (in %) of Nigeria in 1976 to that in 1981?
Offer a very short reply. 0.99. What is the ratio of the Value added (in %) in South Africa in 1976 to that in 1981?
Your response must be concise. 0.96. What is the ratio of the Value added (in %) of Iran in 1976 to that in 1982?
Keep it short and to the point. 1.13. What is the ratio of the Value added (in %) in Kenya in 1976 to that in 1982?
Give a very brief answer. 0.97. What is the ratio of the Value added (in %) of Nigeria in 1976 to that in 1982?
Offer a terse response. 0.91. What is the ratio of the Value added (in %) of Iran in 1980 to that in 1981?
Your answer should be compact. 1.29. What is the ratio of the Value added (in %) of Kenya in 1980 to that in 1981?
Offer a terse response. 0.94. What is the ratio of the Value added (in %) in Nigeria in 1980 to that in 1981?
Offer a terse response. 0.78. What is the ratio of the Value added (in %) of South Africa in 1980 to that in 1981?
Your response must be concise. 1.01. What is the ratio of the Value added (in %) in Iran in 1980 to that in 1982?
Offer a terse response. 1.33. What is the ratio of the Value added (in %) of Kenya in 1980 to that in 1982?
Provide a succinct answer. 1.01. What is the ratio of the Value added (in %) of Nigeria in 1980 to that in 1982?
Provide a succinct answer. 0.72. What is the ratio of the Value added (in %) in South Africa in 1980 to that in 1982?
Give a very brief answer. 1.05. What is the ratio of the Value added (in %) in Iran in 1981 to that in 1982?
Make the answer very short. 1.03. What is the ratio of the Value added (in %) of Kenya in 1981 to that in 1982?
Your answer should be compact. 1.07. What is the ratio of the Value added (in %) in Nigeria in 1981 to that in 1982?
Your response must be concise. 0.92. What is the ratio of the Value added (in %) in South Africa in 1981 to that in 1982?
Offer a terse response. 1.04. What is the difference between the highest and the second highest Value added (in %) in Iran?
Ensure brevity in your answer.  8.17. What is the difference between the highest and the second highest Value added (in %) in Kenya?
Your answer should be compact. 0.17. What is the difference between the highest and the second highest Value added (in %) in Nigeria?
Provide a succinct answer. 3.82. What is the difference between the highest and the second highest Value added (in %) of South Africa?
Ensure brevity in your answer.  0.65. What is the difference between the highest and the lowest Value added (in %) of Iran?
Provide a succinct answer. 19.31. What is the difference between the highest and the lowest Value added (in %) in Kenya?
Make the answer very short. 7.36. What is the difference between the highest and the lowest Value added (in %) in Nigeria?
Make the answer very short. 12.96. What is the difference between the highest and the lowest Value added (in %) in South Africa?
Ensure brevity in your answer.  5.12. 